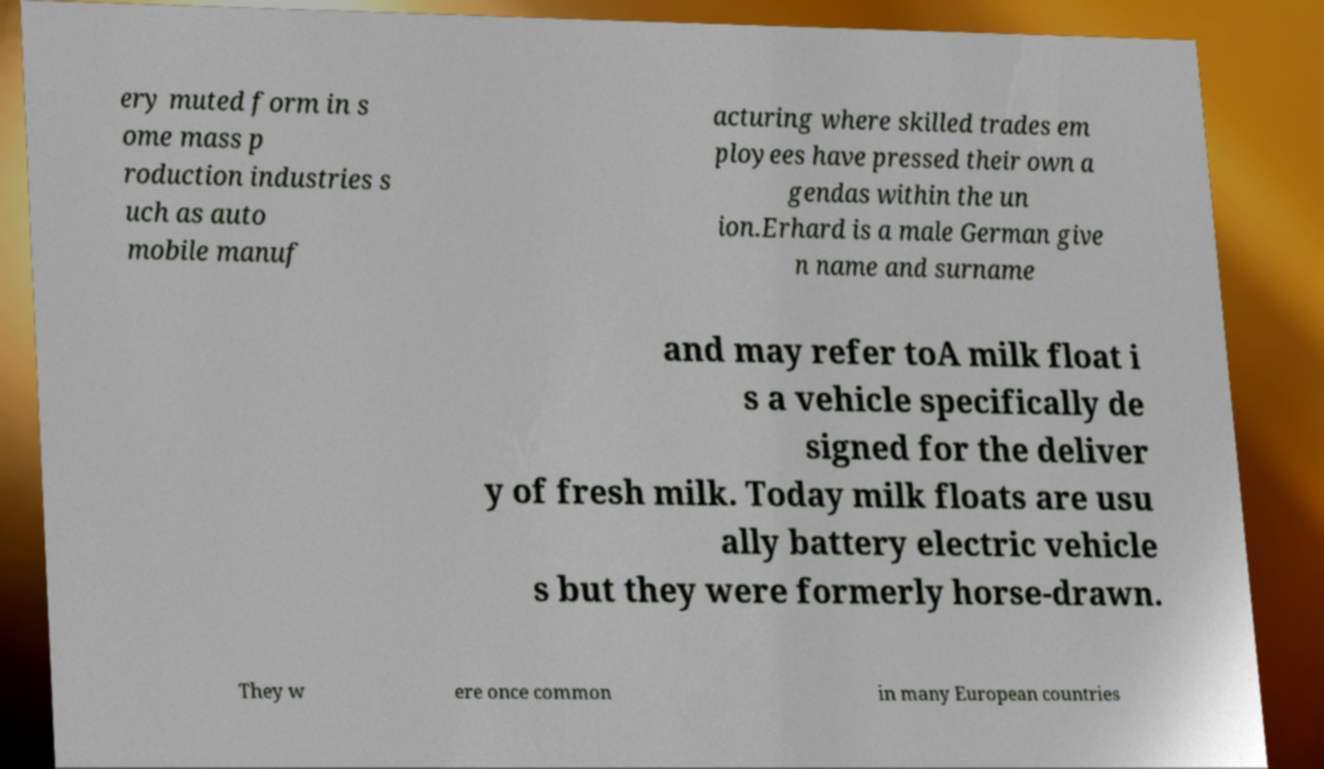Please identify and transcribe the text found in this image. ery muted form in s ome mass p roduction industries s uch as auto mobile manuf acturing where skilled trades em ployees have pressed their own a gendas within the un ion.Erhard is a male German give n name and surname and may refer toA milk float i s a vehicle specifically de signed for the deliver y of fresh milk. Today milk floats are usu ally battery electric vehicle s but they were formerly horse-drawn. They w ere once common in many European countries 